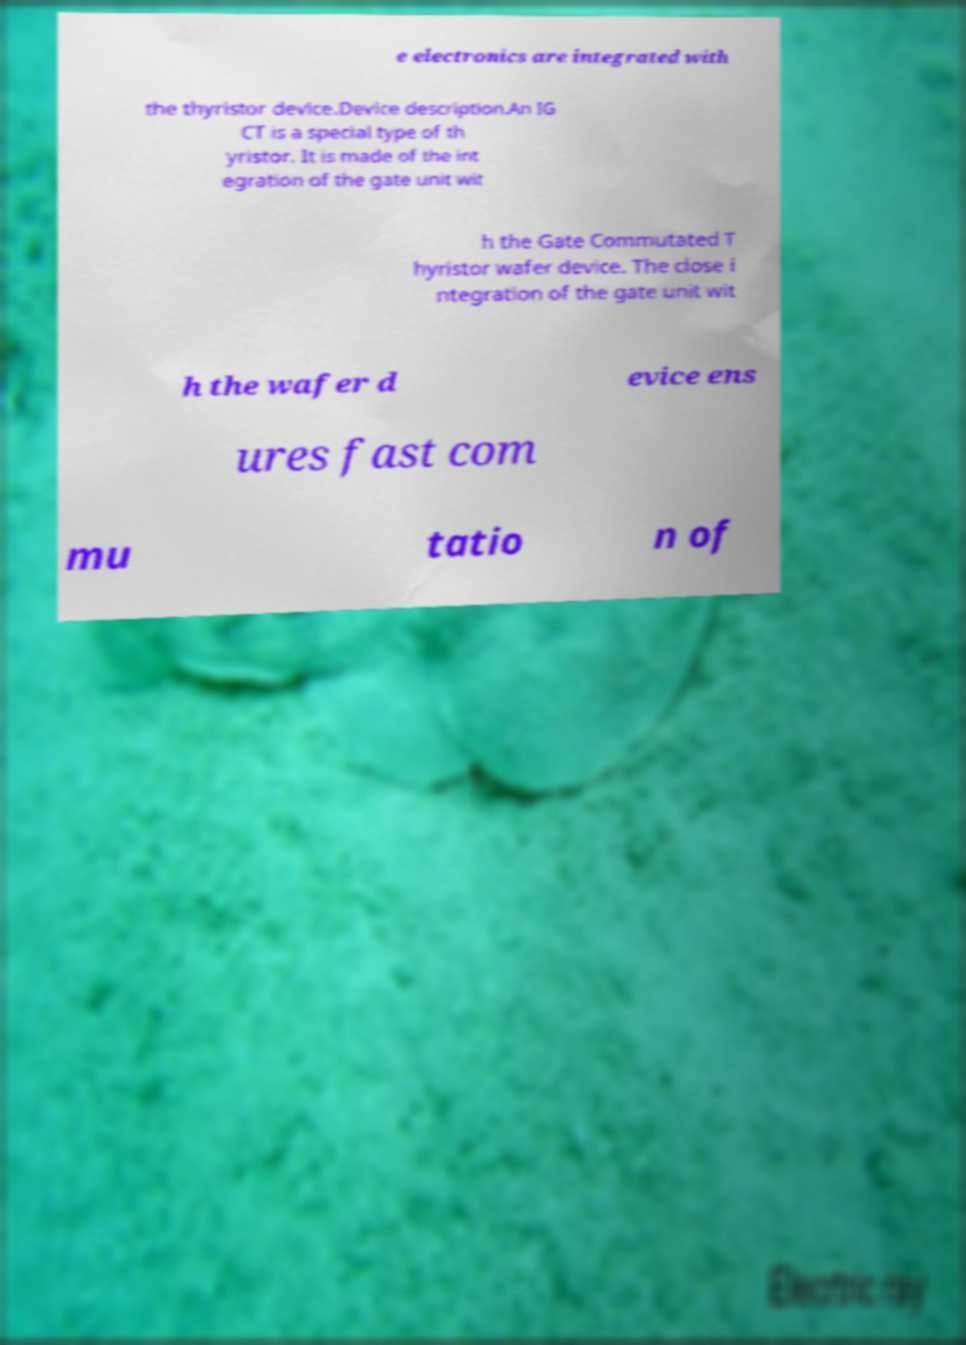Please identify and transcribe the text found in this image. e electronics are integrated with the thyristor device.Device description.An IG CT is a special type of th yristor. It is made of the int egration of the gate unit wit h the Gate Commutated T hyristor wafer device. The close i ntegration of the gate unit wit h the wafer d evice ens ures fast com mu tatio n of 